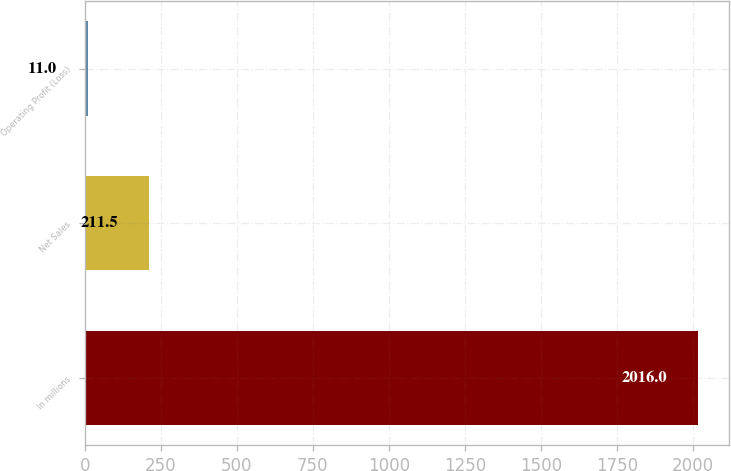Convert chart. <chart><loc_0><loc_0><loc_500><loc_500><bar_chart><fcel>In millions<fcel>Net Sales<fcel>Operating Profit (Loss)<nl><fcel>2016<fcel>211.5<fcel>11<nl></chart> 